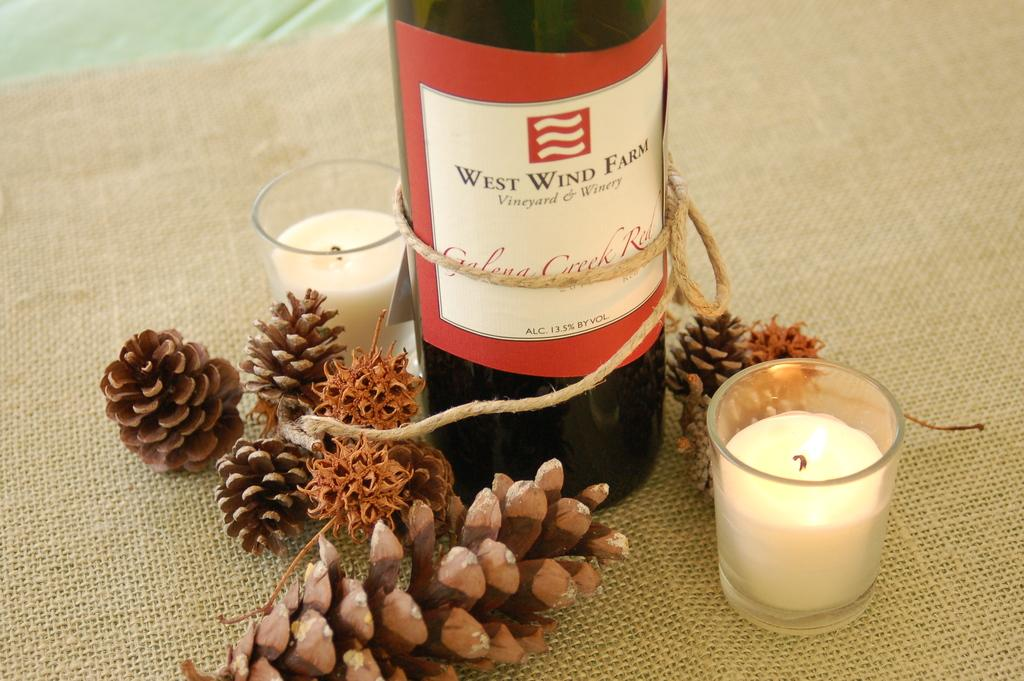What is located in the foreground of the image? In the foreground of the image, there is a bottle, two glass candles, and lines on a mat-like structure. Can you describe the bottle in the image? The bottle is located in the foreground of the image. What objects are near the bottle in the image? Near the bottle, there are two glass candles and lines on a mat-like structure. What is the texture or pattern of the mat-like structure in the image? The mat-like structure in the foreground of the image has lines on it. What type of rings does the dad wear in the image? There is no dad or rings present in the image. 